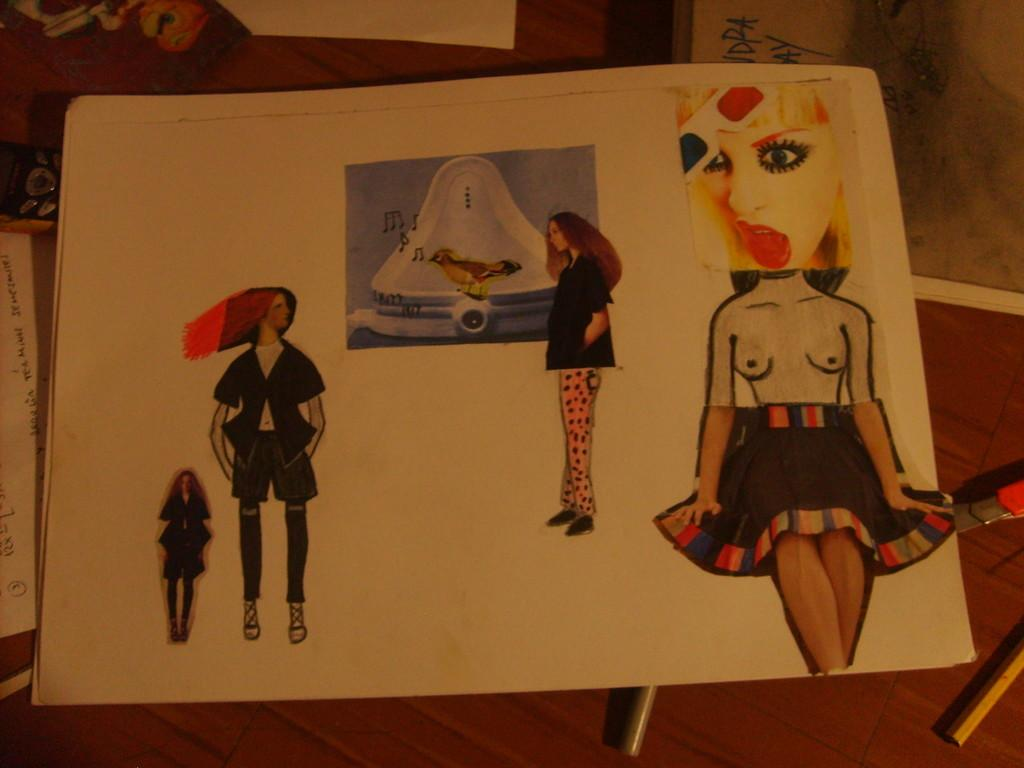What piece of furniture is present in the image? There is a table in the image. What is placed on the table? There is a book, papers, a mobile, and pens on the table. Can you describe the contents of the papers? Pictures of ladies are pasted on one of the papers. What grade did the student receive on the example paper in the image? There is no example paper or mention of a grade in the image. 